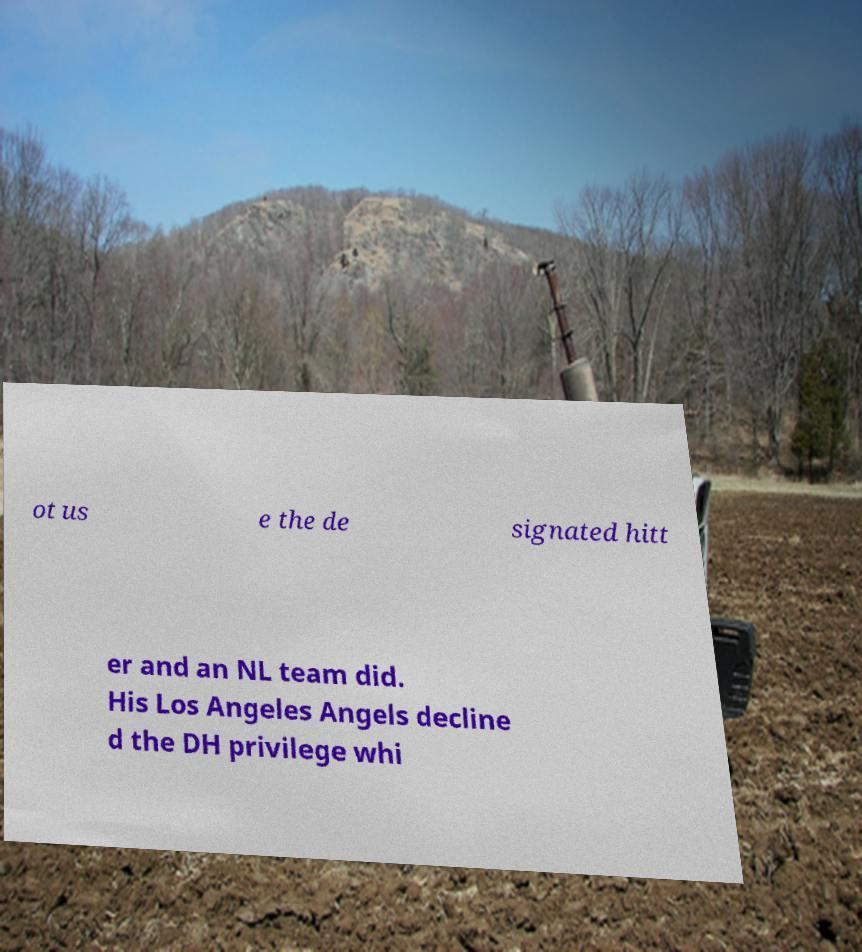Please read and relay the text visible in this image. What does it say? ot us e the de signated hitt er and an NL team did. His Los Angeles Angels decline d the DH privilege whi 